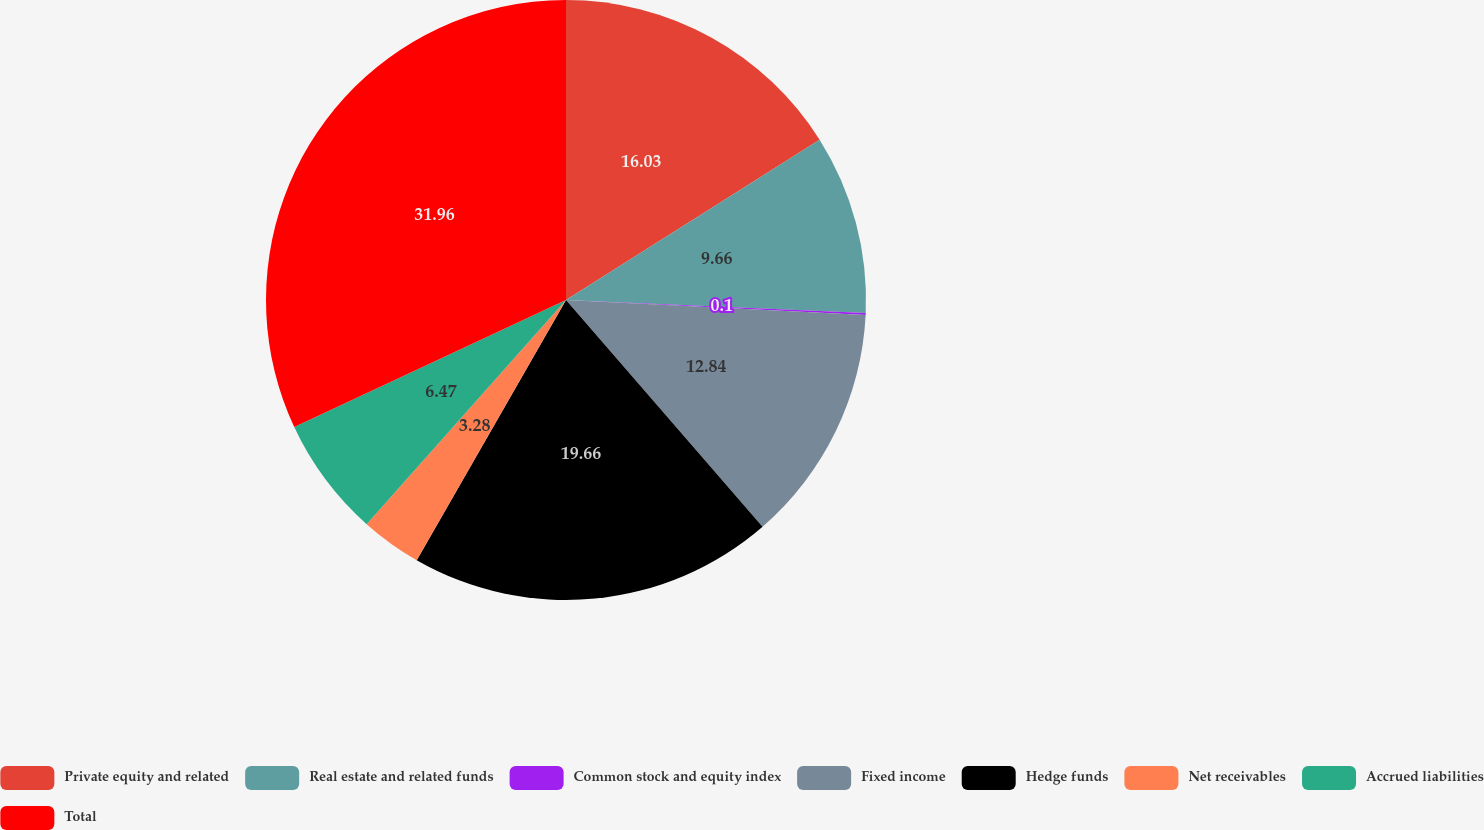<chart> <loc_0><loc_0><loc_500><loc_500><pie_chart><fcel>Private equity and related<fcel>Real estate and related funds<fcel>Common stock and equity index<fcel>Fixed income<fcel>Hedge funds<fcel>Net receivables<fcel>Accrued liabilities<fcel>Total<nl><fcel>16.03%<fcel>9.66%<fcel>0.1%<fcel>12.84%<fcel>19.66%<fcel>3.28%<fcel>6.47%<fcel>31.96%<nl></chart> 